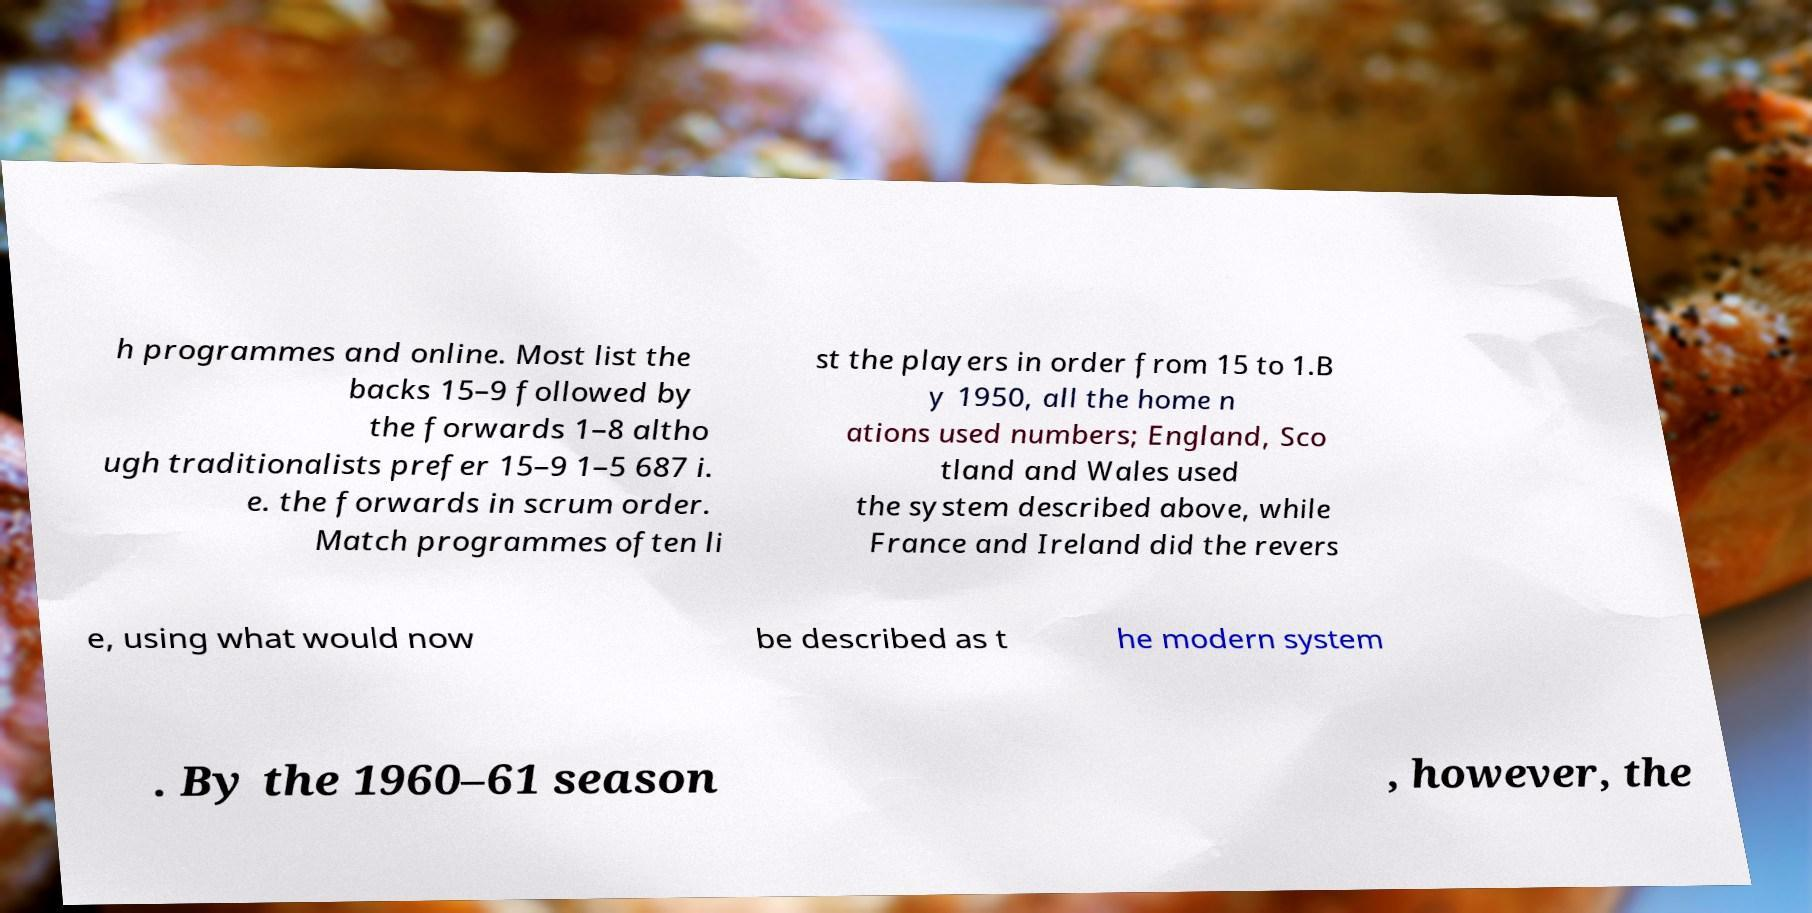Please read and relay the text visible in this image. What does it say? h programmes and online. Most list the backs 15–9 followed by the forwards 1–8 altho ugh traditionalists prefer 15–9 1–5 687 i. e. the forwards in scrum order. Match programmes often li st the players in order from 15 to 1.B y 1950, all the home n ations used numbers; England, Sco tland and Wales used the system described above, while France and Ireland did the revers e, using what would now be described as t he modern system . By the 1960–61 season , however, the 